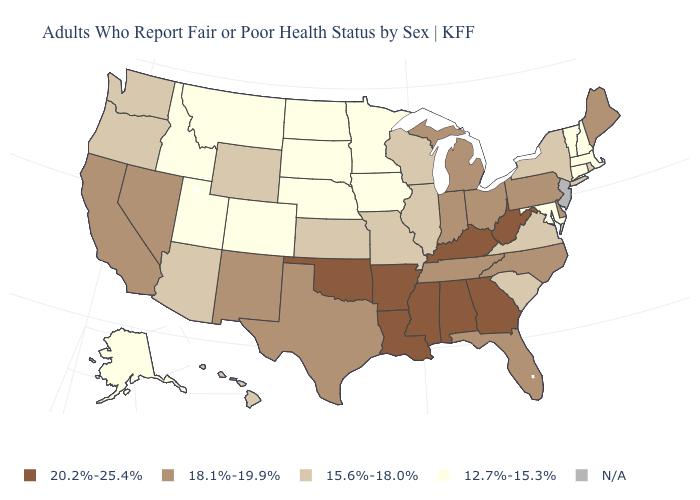Among the states that border Oregon , does Washington have the lowest value?
Answer briefly. No. What is the value of Florida?
Answer briefly. 18.1%-19.9%. Which states hav the highest value in the West?
Be succinct. California, Nevada, New Mexico. What is the value of Missouri?
Be succinct. 15.6%-18.0%. What is the value of Kansas?
Keep it brief. 15.6%-18.0%. What is the value of Mississippi?
Give a very brief answer. 20.2%-25.4%. Name the states that have a value in the range N/A?
Short answer required. New Jersey. What is the value of South Dakota?
Concise answer only. 12.7%-15.3%. Does Georgia have the highest value in the USA?
Answer briefly. Yes. Name the states that have a value in the range 12.7%-15.3%?
Write a very short answer. Alaska, Colorado, Connecticut, Idaho, Iowa, Maryland, Massachusetts, Minnesota, Montana, Nebraska, New Hampshire, North Dakota, South Dakota, Utah, Vermont. Among the states that border Alabama , does Florida have the lowest value?
Concise answer only. Yes. Among the states that border Georgia , which have the lowest value?
Write a very short answer. South Carolina. What is the value of North Carolina?
Write a very short answer. 18.1%-19.9%. What is the lowest value in the USA?
Be succinct. 12.7%-15.3%. What is the value of Texas?
Give a very brief answer. 18.1%-19.9%. 